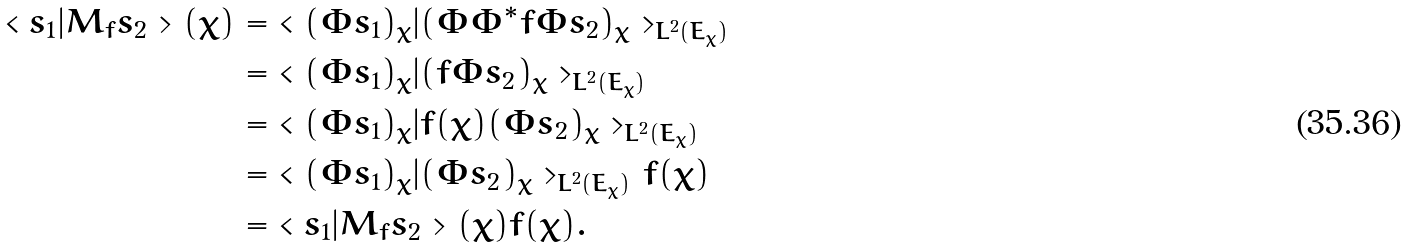<formula> <loc_0><loc_0><loc_500><loc_500>\ < s _ { 1 } | M _ { f } s _ { 2 } > ( \chi ) & = \ < ( \Phi s _ { 1 } ) _ { \chi } | ( \Phi \Phi ^ { * } f \Phi s _ { 2 } ) _ { \chi } > _ { L ^ { 2 } ( E _ { \chi } ) } \\ & = \ < ( \Phi s _ { 1 } ) _ { \chi } | ( f \Phi s _ { 2 } ) _ { \chi } > _ { L ^ { 2 } ( E _ { \chi } ) } \\ & = \ < ( \Phi s _ { 1 } ) _ { \chi } | f ( \chi ) ( \Phi s _ { 2 } ) _ { \chi } > _ { L ^ { 2 } ( E _ { \chi } ) } \\ & = \ < ( \Phi s _ { 1 } ) _ { \chi } | ( \Phi s _ { 2 } ) _ { \chi } > _ { L ^ { 2 } ( E _ { \chi } ) } f ( \chi ) \\ & = \ < s _ { 1 } | M _ { f } s _ { 2 } > ( \chi ) f ( \chi ) .</formula> 